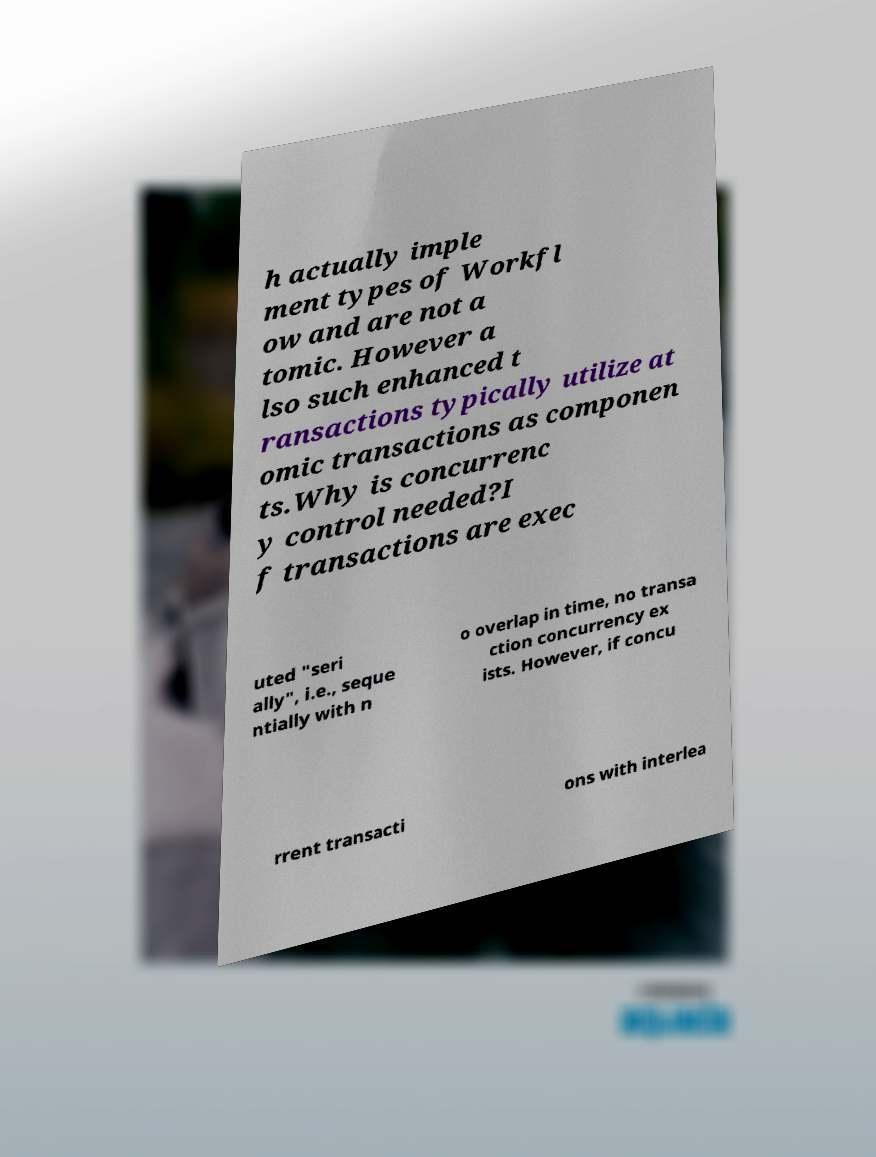Could you assist in decoding the text presented in this image and type it out clearly? h actually imple ment types of Workfl ow and are not a tomic. However a lso such enhanced t ransactions typically utilize at omic transactions as componen ts.Why is concurrenc y control needed?I f transactions are exec uted "seri ally", i.e., seque ntially with n o overlap in time, no transa ction concurrency ex ists. However, if concu rrent transacti ons with interlea 